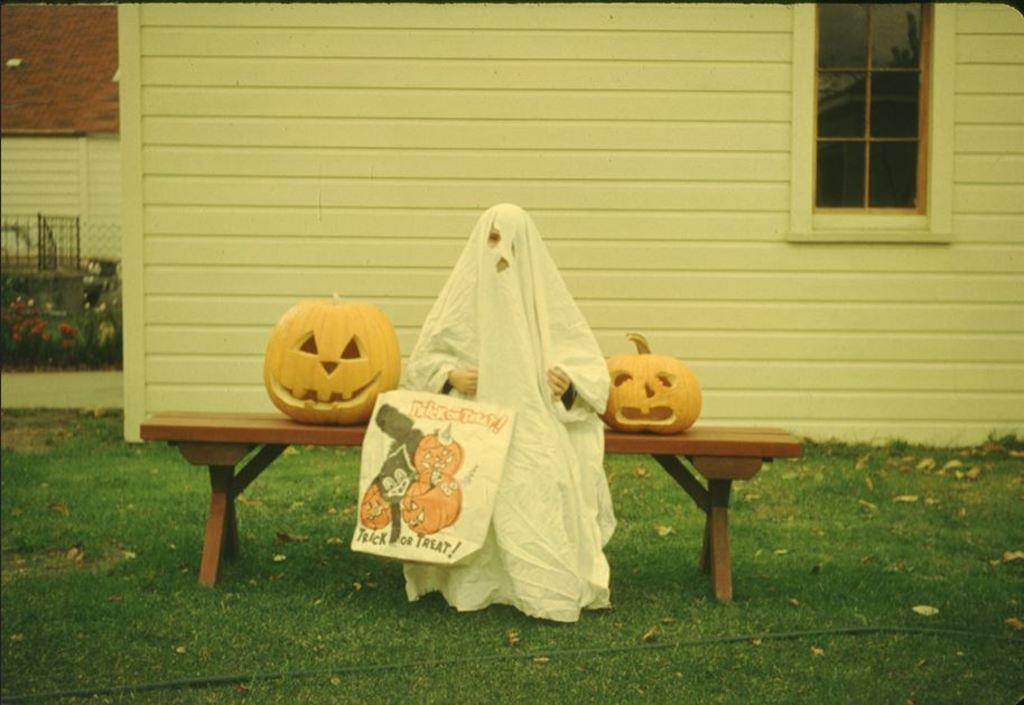What is the person in the image doing? The person is sitting on a bench. What is the person wearing? The person is wearing a white cloth. What objects are near the person? There are two pumpkins, one on each side of the person. What can be seen in the background of the image? There is a building in the background of the image. What type of behavior is the person exhibiting towards the pollution in the image? There is no mention of pollution in the image, so it is not possible to determine the person's behavior towards it. 